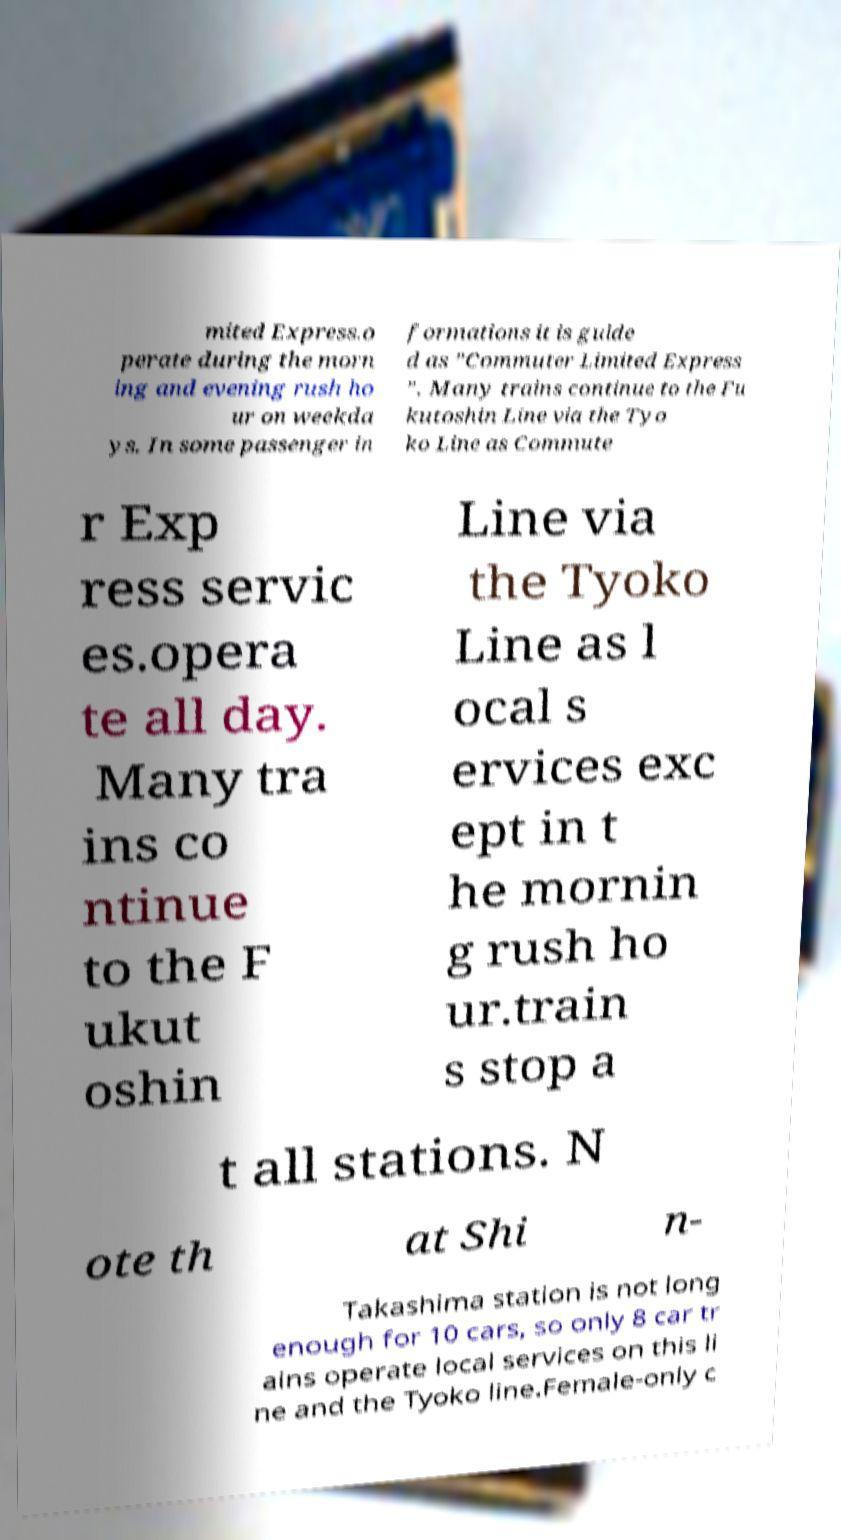There's text embedded in this image that I need extracted. Can you transcribe it verbatim? mited Express.o perate during the morn ing and evening rush ho ur on weekda ys. In some passenger in formations it is guide d as ”Commuter Limited Express ”. Many trains continue to the Fu kutoshin Line via the Tyo ko Line as Commute r Exp ress servic es.opera te all day. Many tra ins co ntinue to the F ukut oshin Line via the Tyoko Line as l ocal s ervices exc ept in t he mornin g rush ho ur.train s stop a t all stations. N ote th at Shi n- Takashima station is not long enough for 10 cars, so only 8 car tr ains operate local services on this li ne and the Tyoko line.Female-only c 